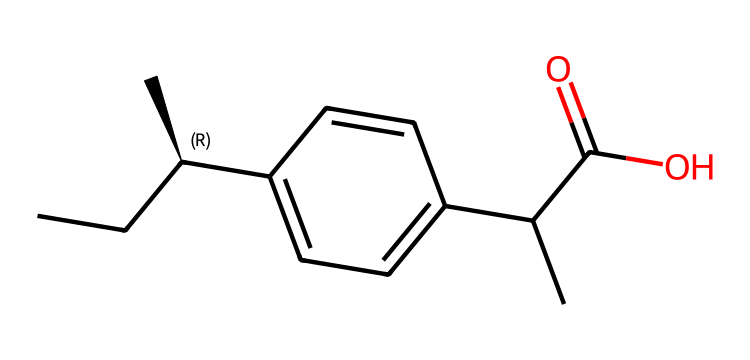How many carbon atoms are in ibuprofen? The SMILES representation shows multiple "C" characters, each representing a carbon atom. By counting the "C" characters, we find there are 13 carbon atoms in total.
Answer: 13 What type of functional group is present in ibuprofen? The presence of the "C(=O)O" in the SMILES indicates a carboxylic acid functional group, characterized by the carbonyl (C=O) and hydroxyl (O–H) groups connected to the same carbon atom.
Answer: carboxylic acid Does ibuprofen have any chiral centers? A chiral center is identified if a carbon atom is attached to four different groups. In the SMILES, the "[C@H]" signifies a chiral carbon, confirming it has at least one chiral center.
Answer: yes How many double bonds does ibuprofen have? The "C(=O)" in the functional group indicates one carbon-oxygen double bond. There are no other double bonds visible in the rest of the structure. Thus, there is only one double bond present.
Answer: 1 What is the significance of the "[C@H]" notation in ibuprofen? The "[C@H]" notation indicates the presence of chirality at that carbon atom, meaning it has a stereocenter that can exist in two different spatial configurations (enantiomers) that can affect the drug's effectiveness.
Answer: chirality 